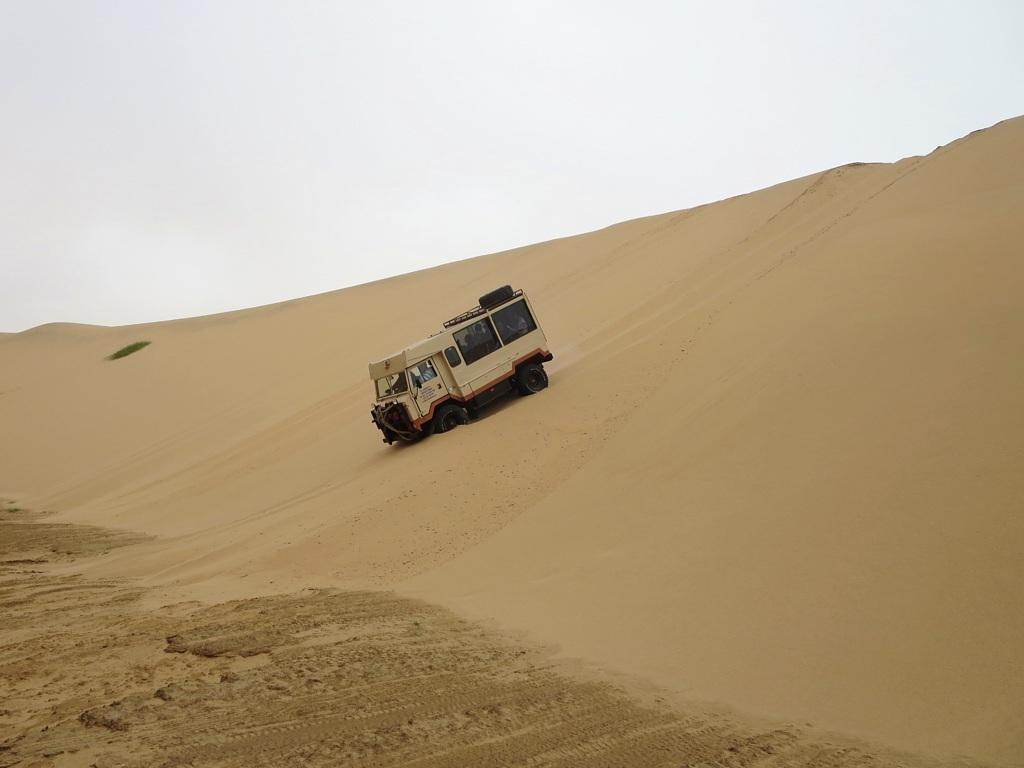What is the main subject of the image? There is a vehicle in the image. Where is the vehicle located? The vehicle is on the sand. What colors can be seen on the vehicle? The vehicle is in cream and black color. What can be seen in the background of the image? The sky is visible in the background of the image. What is the color of the sky in the image? The sky is white in the image. What type of hair can be seen on the vehicle in the image? There is no hair present on the vehicle in the image. What kind of pest is visible on the sand near the vehicle? There is no pest visible on the sand near the vehicle in the image. 